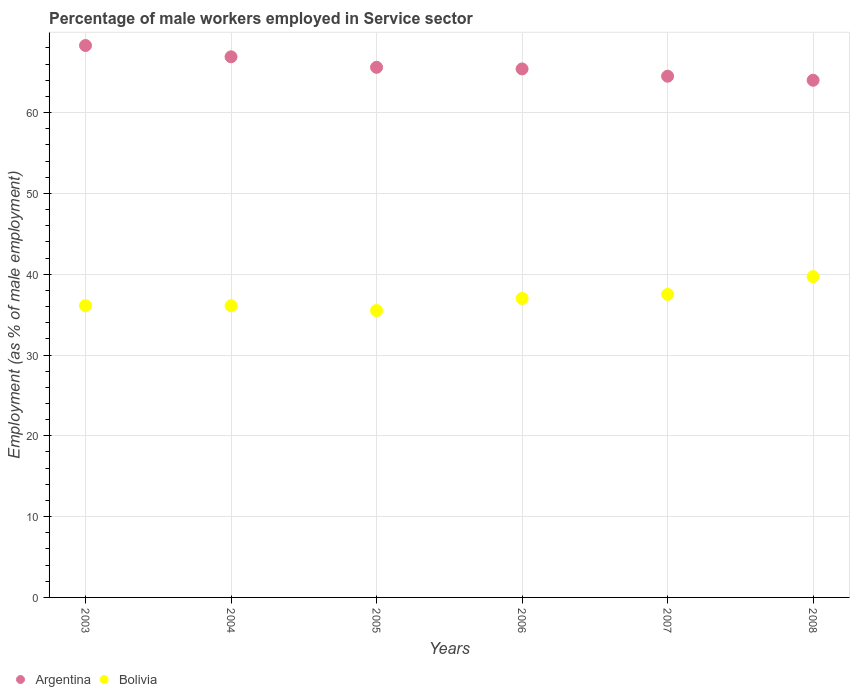How many different coloured dotlines are there?
Keep it short and to the point. 2. What is the percentage of male workers employed in Service sector in Argentina in 2003?
Provide a succinct answer. 68.3. Across all years, what is the maximum percentage of male workers employed in Service sector in Argentina?
Provide a short and direct response. 68.3. Across all years, what is the minimum percentage of male workers employed in Service sector in Argentina?
Provide a short and direct response. 64. In which year was the percentage of male workers employed in Service sector in Argentina minimum?
Your answer should be very brief. 2008. What is the total percentage of male workers employed in Service sector in Argentina in the graph?
Your answer should be very brief. 394.7. What is the difference between the percentage of male workers employed in Service sector in Bolivia in 2004 and that in 2006?
Provide a short and direct response. -0.9. What is the difference between the percentage of male workers employed in Service sector in Argentina in 2005 and the percentage of male workers employed in Service sector in Bolivia in 2008?
Your response must be concise. 25.9. What is the average percentage of male workers employed in Service sector in Argentina per year?
Provide a short and direct response. 65.78. In the year 2005, what is the difference between the percentage of male workers employed in Service sector in Bolivia and percentage of male workers employed in Service sector in Argentina?
Offer a very short reply. -30.1. What is the ratio of the percentage of male workers employed in Service sector in Bolivia in 2003 to that in 2008?
Your answer should be very brief. 0.91. Is the percentage of male workers employed in Service sector in Bolivia in 2003 less than that in 2006?
Ensure brevity in your answer.  Yes. What is the difference between the highest and the second highest percentage of male workers employed in Service sector in Bolivia?
Keep it short and to the point. 2.2. What is the difference between the highest and the lowest percentage of male workers employed in Service sector in Bolivia?
Provide a succinct answer. 4.2. In how many years, is the percentage of male workers employed in Service sector in Bolivia greater than the average percentage of male workers employed in Service sector in Bolivia taken over all years?
Provide a succinct answer. 3. Is the sum of the percentage of male workers employed in Service sector in Argentina in 2003 and 2008 greater than the maximum percentage of male workers employed in Service sector in Bolivia across all years?
Give a very brief answer. Yes. Is the percentage of male workers employed in Service sector in Bolivia strictly less than the percentage of male workers employed in Service sector in Argentina over the years?
Give a very brief answer. Yes. How many years are there in the graph?
Your answer should be compact. 6. Are the values on the major ticks of Y-axis written in scientific E-notation?
Offer a terse response. No. Does the graph contain grids?
Provide a short and direct response. Yes. Where does the legend appear in the graph?
Provide a succinct answer. Bottom left. How are the legend labels stacked?
Your answer should be very brief. Horizontal. What is the title of the graph?
Provide a succinct answer. Percentage of male workers employed in Service sector. What is the label or title of the Y-axis?
Offer a terse response. Employment (as % of male employment). What is the Employment (as % of male employment) in Argentina in 2003?
Provide a succinct answer. 68.3. What is the Employment (as % of male employment) in Bolivia in 2003?
Make the answer very short. 36.1. What is the Employment (as % of male employment) of Argentina in 2004?
Keep it short and to the point. 66.9. What is the Employment (as % of male employment) in Bolivia in 2004?
Give a very brief answer. 36.1. What is the Employment (as % of male employment) of Argentina in 2005?
Offer a very short reply. 65.6. What is the Employment (as % of male employment) in Bolivia in 2005?
Ensure brevity in your answer.  35.5. What is the Employment (as % of male employment) in Argentina in 2006?
Your answer should be compact. 65.4. What is the Employment (as % of male employment) of Argentina in 2007?
Keep it short and to the point. 64.5. What is the Employment (as % of male employment) in Bolivia in 2007?
Your answer should be compact. 37.5. What is the Employment (as % of male employment) in Bolivia in 2008?
Offer a very short reply. 39.7. Across all years, what is the maximum Employment (as % of male employment) in Argentina?
Make the answer very short. 68.3. Across all years, what is the maximum Employment (as % of male employment) in Bolivia?
Keep it short and to the point. 39.7. Across all years, what is the minimum Employment (as % of male employment) of Bolivia?
Your response must be concise. 35.5. What is the total Employment (as % of male employment) of Argentina in the graph?
Provide a short and direct response. 394.7. What is the total Employment (as % of male employment) of Bolivia in the graph?
Keep it short and to the point. 221.9. What is the difference between the Employment (as % of male employment) of Argentina in 2003 and that in 2004?
Your answer should be very brief. 1.4. What is the difference between the Employment (as % of male employment) of Argentina in 2003 and that in 2005?
Offer a terse response. 2.7. What is the difference between the Employment (as % of male employment) in Argentina in 2003 and that in 2007?
Give a very brief answer. 3.8. What is the difference between the Employment (as % of male employment) of Argentina in 2003 and that in 2008?
Give a very brief answer. 4.3. What is the difference between the Employment (as % of male employment) of Bolivia in 2003 and that in 2008?
Your response must be concise. -3.6. What is the difference between the Employment (as % of male employment) of Argentina in 2004 and that in 2005?
Offer a very short reply. 1.3. What is the difference between the Employment (as % of male employment) in Bolivia in 2004 and that in 2006?
Your answer should be very brief. -0.9. What is the difference between the Employment (as % of male employment) of Argentina in 2004 and that in 2007?
Make the answer very short. 2.4. What is the difference between the Employment (as % of male employment) of Argentina in 2004 and that in 2008?
Ensure brevity in your answer.  2.9. What is the difference between the Employment (as % of male employment) in Bolivia in 2004 and that in 2008?
Ensure brevity in your answer.  -3.6. What is the difference between the Employment (as % of male employment) in Argentina in 2005 and that in 2006?
Provide a short and direct response. 0.2. What is the difference between the Employment (as % of male employment) in Bolivia in 2005 and that in 2006?
Offer a terse response. -1.5. What is the difference between the Employment (as % of male employment) of Bolivia in 2005 and that in 2007?
Keep it short and to the point. -2. What is the difference between the Employment (as % of male employment) in Bolivia in 2005 and that in 2008?
Ensure brevity in your answer.  -4.2. What is the difference between the Employment (as % of male employment) in Bolivia in 2006 and that in 2007?
Your answer should be very brief. -0.5. What is the difference between the Employment (as % of male employment) of Argentina in 2007 and that in 2008?
Offer a very short reply. 0.5. What is the difference between the Employment (as % of male employment) in Bolivia in 2007 and that in 2008?
Ensure brevity in your answer.  -2.2. What is the difference between the Employment (as % of male employment) of Argentina in 2003 and the Employment (as % of male employment) of Bolivia in 2004?
Offer a very short reply. 32.2. What is the difference between the Employment (as % of male employment) of Argentina in 2003 and the Employment (as % of male employment) of Bolivia in 2005?
Offer a very short reply. 32.8. What is the difference between the Employment (as % of male employment) in Argentina in 2003 and the Employment (as % of male employment) in Bolivia in 2006?
Ensure brevity in your answer.  31.3. What is the difference between the Employment (as % of male employment) in Argentina in 2003 and the Employment (as % of male employment) in Bolivia in 2007?
Keep it short and to the point. 30.8. What is the difference between the Employment (as % of male employment) of Argentina in 2003 and the Employment (as % of male employment) of Bolivia in 2008?
Provide a short and direct response. 28.6. What is the difference between the Employment (as % of male employment) of Argentina in 2004 and the Employment (as % of male employment) of Bolivia in 2005?
Provide a short and direct response. 31.4. What is the difference between the Employment (as % of male employment) in Argentina in 2004 and the Employment (as % of male employment) in Bolivia in 2006?
Provide a succinct answer. 29.9. What is the difference between the Employment (as % of male employment) in Argentina in 2004 and the Employment (as % of male employment) in Bolivia in 2007?
Your answer should be very brief. 29.4. What is the difference between the Employment (as % of male employment) of Argentina in 2004 and the Employment (as % of male employment) of Bolivia in 2008?
Provide a short and direct response. 27.2. What is the difference between the Employment (as % of male employment) of Argentina in 2005 and the Employment (as % of male employment) of Bolivia in 2006?
Your response must be concise. 28.6. What is the difference between the Employment (as % of male employment) of Argentina in 2005 and the Employment (as % of male employment) of Bolivia in 2007?
Keep it short and to the point. 28.1. What is the difference between the Employment (as % of male employment) in Argentina in 2005 and the Employment (as % of male employment) in Bolivia in 2008?
Provide a succinct answer. 25.9. What is the difference between the Employment (as % of male employment) in Argentina in 2006 and the Employment (as % of male employment) in Bolivia in 2007?
Your answer should be very brief. 27.9. What is the difference between the Employment (as % of male employment) of Argentina in 2006 and the Employment (as % of male employment) of Bolivia in 2008?
Offer a terse response. 25.7. What is the difference between the Employment (as % of male employment) in Argentina in 2007 and the Employment (as % of male employment) in Bolivia in 2008?
Provide a succinct answer. 24.8. What is the average Employment (as % of male employment) in Argentina per year?
Provide a succinct answer. 65.78. What is the average Employment (as % of male employment) in Bolivia per year?
Provide a succinct answer. 36.98. In the year 2003, what is the difference between the Employment (as % of male employment) of Argentina and Employment (as % of male employment) of Bolivia?
Offer a terse response. 32.2. In the year 2004, what is the difference between the Employment (as % of male employment) in Argentina and Employment (as % of male employment) in Bolivia?
Provide a succinct answer. 30.8. In the year 2005, what is the difference between the Employment (as % of male employment) in Argentina and Employment (as % of male employment) in Bolivia?
Your answer should be very brief. 30.1. In the year 2006, what is the difference between the Employment (as % of male employment) in Argentina and Employment (as % of male employment) in Bolivia?
Make the answer very short. 28.4. In the year 2007, what is the difference between the Employment (as % of male employment) of Argentina and Employment (as % of male employment) of Bolivia?
Keep it short and to the point. 27. In the year 2008, what is the difference between the Employment (as % of male employment) in Argentina and Employment (as % of male employment) in Bolivia?
Provide a short and direct response. 24.3. What is the ratio of the Employment (as % of male employment) of Argentina in 2003 to that in 2004?
Make the answer very short. 1.02. What is the ratio of the Employment (as % of male employment) of Argentina in 2003 to that in 2005?
Your answer should be very brief. 1.04. What is the ratio of the Employment (as % of male employment) in Bolivia in 2003 to that in 2005?
Ensure brevity in your answer.  1.02. What is the ratio of the Employment (as % of male employment) of Argentina in 2003 to that in 2006?
Provide a succinct answer. 1.04. What is the ratio of the Employment (as % of male employment) of Bolivia in 2003 to that in 2006?
Give a very brief answer. 0.98. What is the ratio of the Employment (as % of male employment) in Argentina in 2003 to that in 2007?
Provide a short and direct response. 1.06. What is the ratio of the Employment (as % of male employment) of Bolivia in 2003 to that in 2007?
Ensure brevity in your answer.  0.96. What is the ratio of the Employment (as % of male employment) of Argentina in 2003 to that in 2008?
Offer a very short reply. 1.07. What is the ratio of the Employment (as % of male employment) of Bolivia in 2003 to that in 2008?
Ensure brevity in your answer.  0.91. What is the ratio of the Employment (as % of male employment) of Argentina in 2004 to that in 2005?
Give a very brief answer. 1.02. What is the ratio of the Employment (as % of male employment) in Bolivia in 2004 to that in 2005?
Your response must be concise. 1.02. What is the ratio of the Employment (as % of male employment) in Argentina in 2004 to that in 2006?
Offer a very short reply. 1.02. What is the ratio of the Employment (as % of male employment) of Bolivia in 2004 to that in 2006?
Offer a very short reply. 0.98. What is the ratio of the Employment (as % of male employment) in Argentina in 2004 to that in 2007?
Provide a succinct answer. 1.04. What is the ratio of the Employment (as % of male employment) in Bolivia in 2004 to that in 2007?
Give a very brief answer. 0.96. What is the ratio of the Employment (as % of male employment) of Argentina in 2004 to that in 2008?
Offer a very short reply. 1.05. What is the ratio of the Employment (as % of male employment) in Bolivia in 2004 to that in 2008?
Offer a very short reply. 0.91. What is the ratio of the Employment (as % of male employment) of Bolivia in 2005 to that in 2006?
Give a very brief answer. 0.96. What is the ratio of the Employment (as % of male employment) of Argentina in 2005 to that in 2007?
Your answer should be compact. 1.02. What is the ratio of the Employment (as % of male employment) in Bolivia in 2005 to that in 2007?
Your answer should be compact. 0.95. What is the ratio of the Employment (as % of male employment) of Bolivia in 2005 to that in 2008?
Keep it short and to the point. 0.89. What is the ratio of the Employment (as % of male employment) in Argentina in 2006 to that in 2007?
Your answer should be compact. 1.01. What is the ratio of the Employment (as % of male employment) in Bolivia in 2006 to that in 2007?
Provide a succinct answer. 0.99. What is the ratio of the Employment (as % of male employment) of Argentina in 2006 to that in 2008?
Provide a short and direct response. 1.02. What is the ratio of the Employment (as % of male employment) in Bolivia in 2006 to that in 2008?
Offer a terse response. 0.93. What is the ratio of the Employment (as % of male employment) of Argentina in 2007 to that in 2008?
Ensure brevity in your answer.  1.01. What is the ratio of the Employment (as % of male employment) of Bolivia in 2007 to that in 2008?
Your answer should be compact. 0.94. What is the difference between the highest and the second highest Employment (as % of male employment) of Bolivia?
Offer a very short reply. 2.2. What is the difference between the highest and the lowest Employment (as % of male employment) of Argentina?
Your answer should be very brief. 4.3. What is the difference between the highest and the lowest Employment (as % of male employment) in Bolivia?
Your answer should be very brief. 4.2. 